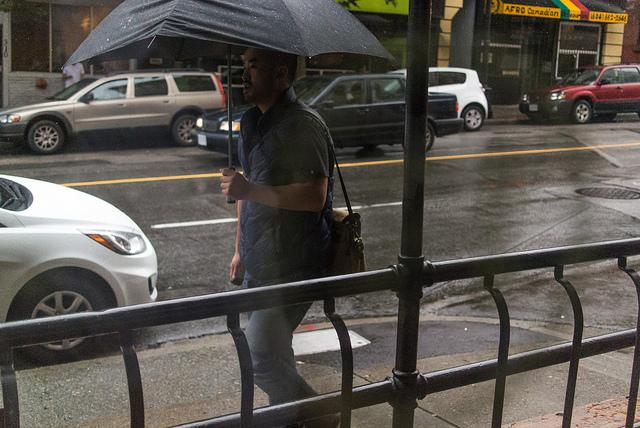From what does the man with the umbrella protect himself? Please explain your reasoning. rain. It is gloomy and the streets are wet. 